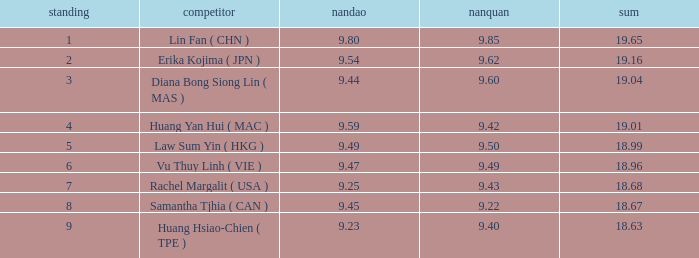Which Nanquan has a Nandao larger than 9.49, and a Rank of 4? 9.42. 